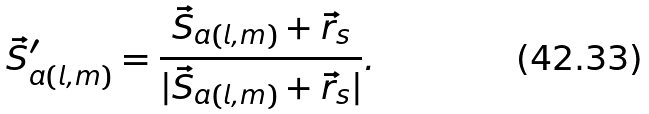<formula> <loc_0><loc_0><loc_500><loc_500>\vec { S } _ { a ( l , m ) } ^ { \prime } = \frac { \vec { S } _ { a ( l , m ) } + \vec { r } _ { s } } { | \vec { S } _ { a ( l , m ) } + \vec { r } _ { s } | } .</formula> 